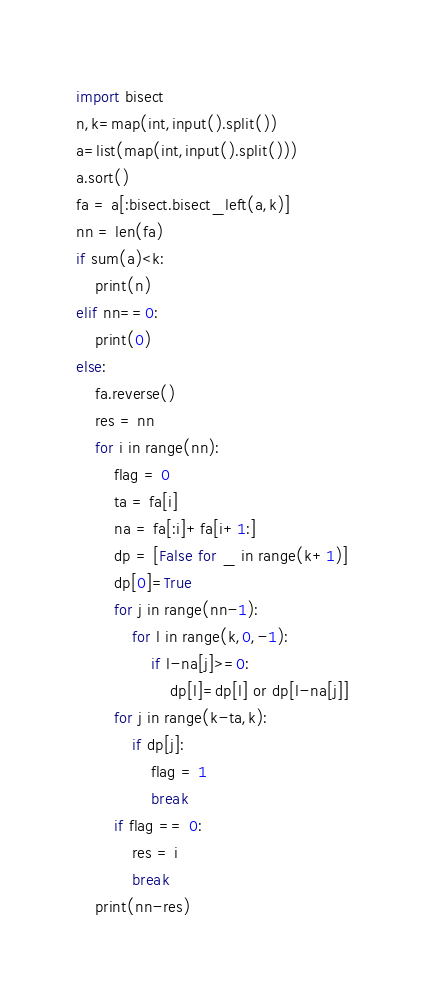Convert code to text. <code><loc_0><loc_0><loc_500><loc_500><_Python_>import bisect
n,k=map(int,input().split())
a=list(map(int,input().split()))
a.sort()
fa = a[:bisect.bisect_left(a,k)]
nn = len(fa)
if sum(a)<k:
    print(n)
elif nn==0:
    print(0)
else:
    fa.reverse()
    res = nn
    for i in range(nn):
        flag = 0
        ta = fa[i]
        na = fa[:i]+fa[i+1:]
        dp = [False for _ in range(k+1)]
        dp[0]=True
        for j in range(nn-1):
            for l in range(k,0,-1):
                if l-na[j]>=0:
                    dp[l]=dp[l] or dp[l-na[j]]
        for j in range(k-ta,k):
            if dp[j]:
                flag = 1
                break
        if flag == 0:
            res = i
            break
    print(nn-res)

</code> 